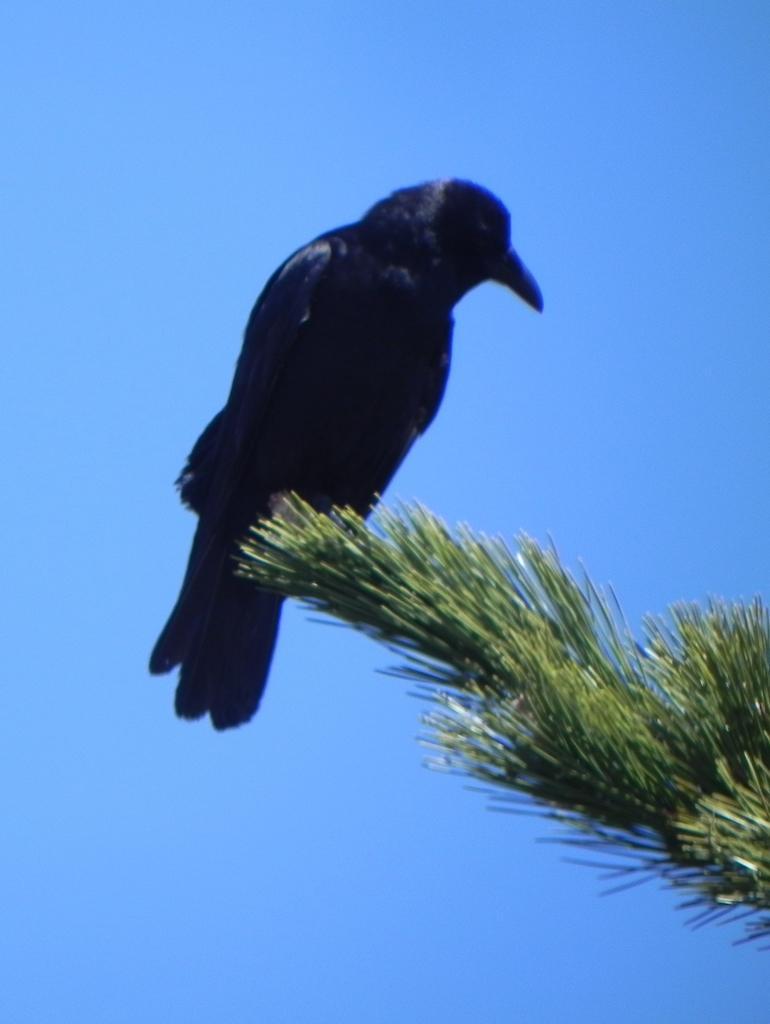Describe this image in one or two sentences. In the center of the image we can see a crow on the tree. In the background there is a sky. 